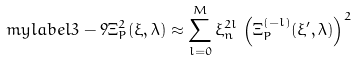<formula> <loc_0><loc_0><loc_500><loc_500>\ m y l a b e l { 3 - 9 } \Xi ^ { 2 } _ { P } ( \xi , \lambda ) \approx \sum _ { l = 0 } ^ { M } \xi _ { n } ^ { 2 l } \, \left ( \Xi _ { P } ^ { ( - l ) } ( \xi ^ { \prime } , \lambda ) \right ) ^ { 2 }</formula> 